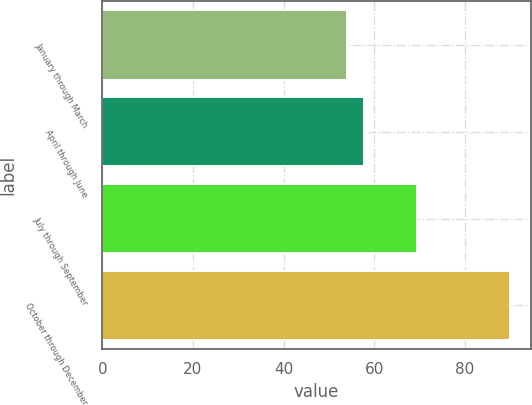Convert chart to OTSL. <chart><loc_0><loc_0><loc_500><loc_500><bar_chart><fcel>January through March<fcel>April through June<fcel>July through September<fcel>October through December<nl><fcel>54.08<fcel>57.67<fcel>69.49<fcel>90.01<nl></chart> 